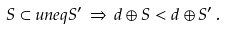<formula> <loc_0><loc_0><loc_500><loc_500>S \subset u n e q S ^ { \prime } \, \Rightarrow \, d \oplus S < d \oplus S ^ { \prime } \, .</formula> 